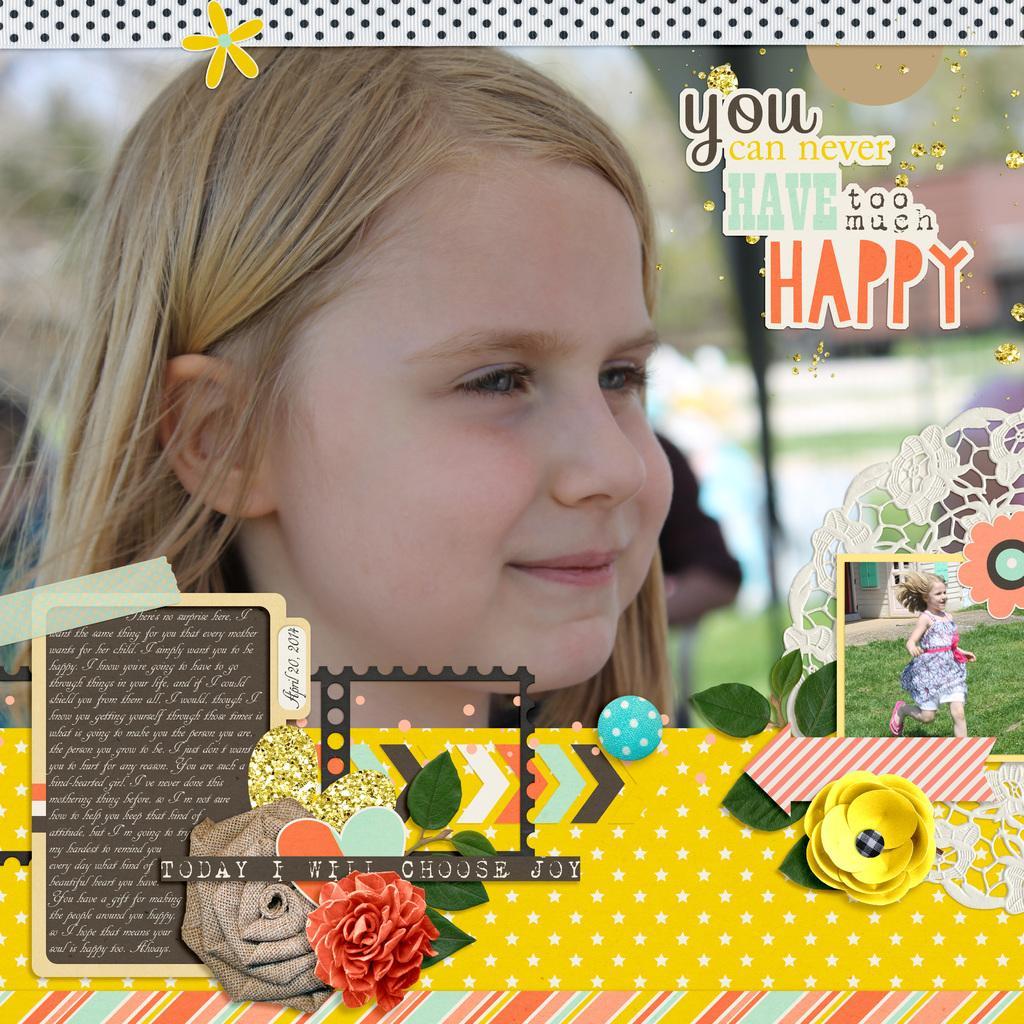How would you summarize this image in a sentence or two? This image is edited one as we can see there is one kid in middle of this image ,and there is some text logo on top right side of this image. and there is some other text logo on the bottom of this image and at top of this image as well. There is one another picture of this kid is on the right side of this image. 